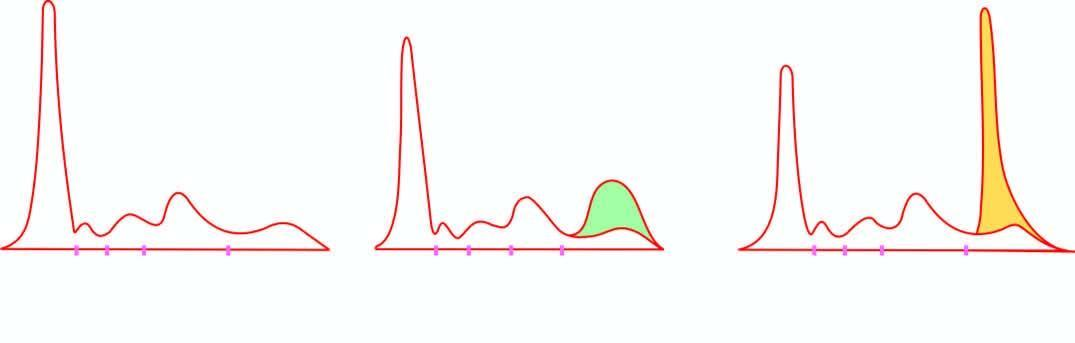did iron show normal serum pattern?
Answer the question using a single word or phrase. No 